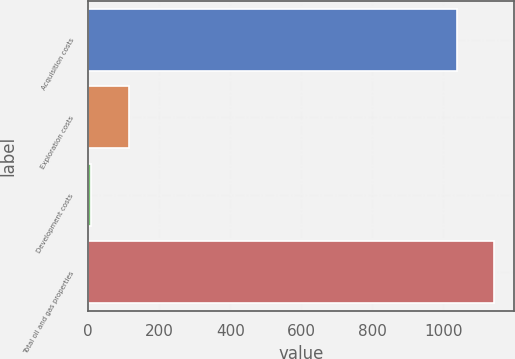<chart> <loc_0><loc_0><loc_500><loc_500><bar_chart><fcel>Acquisition costs<fcel>Exploration costs<fcel>Development costs<fcel>Total oil and gas properties<nl><fcel>1037<fcel>113.8<fcel>9<fcel>1141.8<nl></chart> 